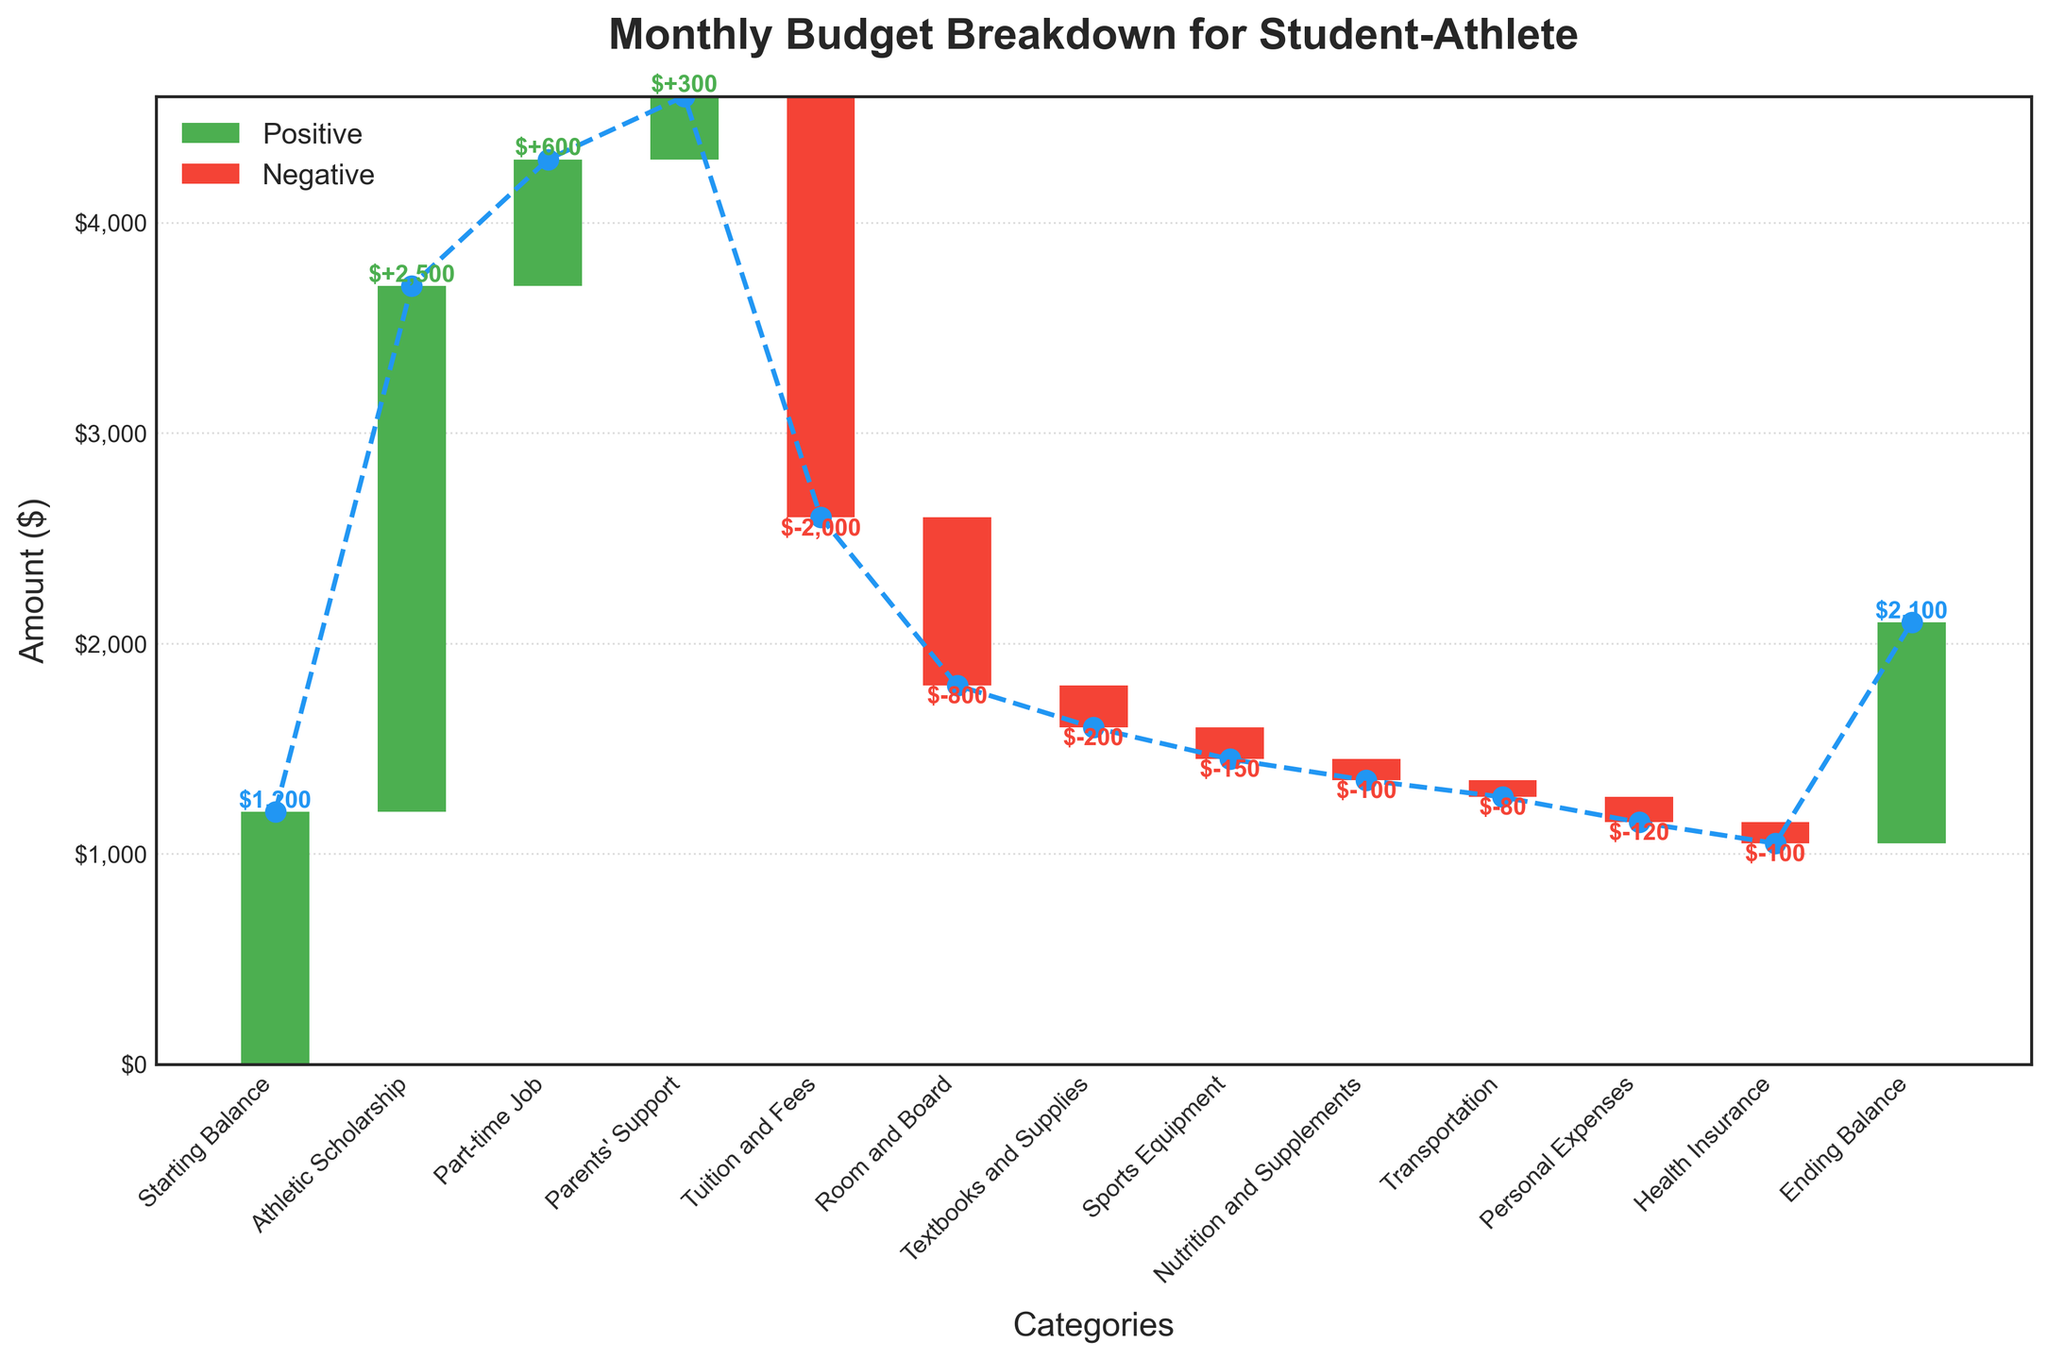What is the total income from all sources? The total income is calculated by summing the positive amounts which are Athletic Scholarship ($2500), Part-time Job ($600), and Parents' Support ($300). Sum = $2500 + $600 + $300
Answer: $3400 What is the final ending balance? The ending balance appears as the last value in the cumulative total displayed on the chart. The ending balance is $1050.
Answer: $1050 Which category has the largest expense? The category with the largest expense will have the highest negative value on the chart, which is Tuition and Fees with -$2000.
Answer: Tuition and Fees What is the net income after expenses, but before the ending balance is calculated? Calculate the net income by adding the starting balance ($1200) and all incomes ($3400), then subtracting all expenses (-$3550). Net amount = $1200 + $3400 - $3550 = $1050.
Answer: $1050 How does the amount of Athletic Scholarship compare to the combination of Room and Board and Textbooks and Supplies? Athletic Scholarship ($2500) compared to the sum of Room and Board and Textbooks and Supplies (-$800 + -$200 = -$1000): $2500 > -$1000.
Answer: Athletic Scholarship is greater What is the accumulated amount after adding the Part-time Job income? Starting from $1200, add Athletic Scholarship ($2500) and then Part-time Job income ($600). Accumulated amount = $1200 + $2500 + $600 = $4300.
Answer: $4300 How much are the total expenses for the month? Add up all the negative amounts: Tuition and Fees (-$2000), Room and Board (-$800), Textbooks and Supplies (-$200), Sports Equipment (-$150), Nutrition and Supplements (-$100), Transportation (-$80), Personal Expenses (-$120), Health Insurance (-$100). Total expenses = -$2000 + -$800 + -$200 + -$150 + -$100 + -$80 + -$120 + -$100 = -$3550.
Answer: $3550 What is the difference between the Starting Balance and the Ending Balance? Subtract the Starting Balance ($1200) from the Ending Balance ($1050). Difference = $1050 - $1200 = -$150.
Answer: -$150 If the parent’s support increased by $200, what would the new ending balance be? Add an extra $200 to Parents' Support ($300 now becomes $500), then recalculate the final balance. New income = 1200 + 2500 + 600 + 500. New expense remains the same (-$3550). New ending balance = (Total new income) - $3550 = $4800 - $3550 = $1250
Answer: $1250 What percentage of the total income comes from the Athletic Scholarship? Athletic Scholarship ($2500) divided by total income ($3400), and multiply by 100 to get percentage: ($2500 / $3400) * 100 = 73.53%.
Answer: 73.53% 